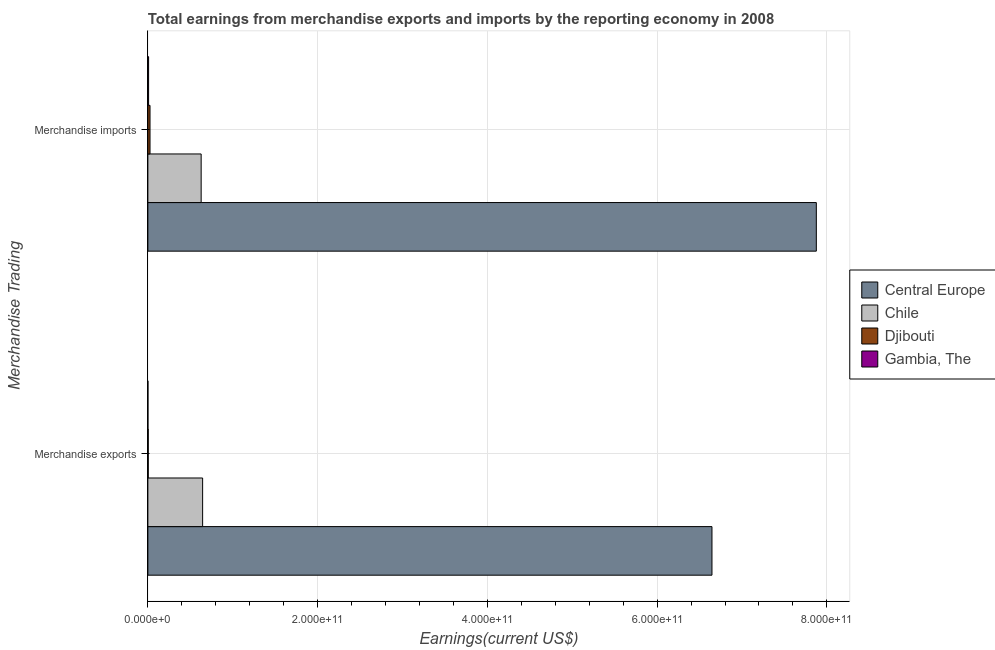How many different coloured bars are there?
Offer a very short reply. 4. How many groups of bars are there?
Provide a short and direct response. 2. What is the earnings from merchandise exports in Chile?
Keep it short and to the point. 6.45e+1. Across all countries, what is the maximum earnings from merchandise imports?
Offer a terse response. 7.88e+11. Across all countries, what is the minimum earnings from merchandise imports?
Ensure brevity in your answer.  8.60e+08. In which country was the earnings from merchandise imports maximum?
Keep it short and to the point. Central Europe. In which country was the earnings from merchandise exports minimum?
Your response must be concise. Gambia, The. What is the total earnings from merchandise imports in the graph?
Provide a short and direct response. 8.54e+11. What is the difference between the earnings from merchandise imports in Djibouti and that in Gambia, The?
Offer a terse response. 1.68e+09. What is the difference between the earnings from merchandise imports in Chile and the earnings from merchandise exports in Djibouti?
Provide a short and direct response. 6.24e+1. What is the average earnings from merchandise imports per country?
Your answer should be compact. 2.13e+11. What is the difference between the earnings from merchandise exports and earnings from merchandise imports in Djibouti?
Give a very brief answer. -2.10e+09. What is the ratio of the earnings from merchandise exports in Djibouti to that in Central Europe?
Make the answer very short. 0. Is the earnings from merchandise imports in Chile less than that in Djibouti?
Offer a terse response. No. In how many countries, is the earnings from merchandise exports greater than the average earnings from merchandise exports taken over all countries?
Offer a very short reply. 1. What does the 2nd bar from the top in Merchandise imports represents?
Give a very brief answer. Djibouti. What does the 4th bar from the bottom in Merchandise imports represents?
Ensure brevity in your answer.  Gambia, The. How many bars are there?
Your answer should be compact. 8. What is the difference between two consecutive major ticks on the X-axis?
Give a very brief answer. 2.00e+11. Are the values on the major ticks of X-axis written in scientific E-notation?
Offer a terse response. Yes. Where does the legend appear in the graph?
Ensure brevity in your answer.  Center right. How many legend labels are there?
Offer a terse response. 4. What is the title of the graph?
Your response must be concise. Total earnings from merchandise exports and imports by the reporting economy in 2008. Does "Argentina" appear as one of the legend labels in the graph?
Ensure brevity in your answer.  No. What is the label or title of the X-axis?
Keep it short and to the point. Earnings(current US$). What is the label or title of the Y-axis?
Provide a succinct answer. Merchandise Trading. What is the Earnings(current US$) of Central Europe in Merchandise exports?
Your response must be concise. 6.65e+11. What is the Earnings(current US$) in Chile in Merchandise exports?
Your answer should be very brief. 6.45e+1. What is the Earnings(current US$) of Djibouti in Merchandise exports?
Keep it short and to the point. 4.36e+08. What is the Earnings(current US$) of Gambia, The in Merchandise exports?
Offer a very short reply. 5.09e+07. What is the Earnings(current US$) in Central Europe in Merchandise imports?
Your answer should be compact. 7.88e+11. What is the Earnings(current US$) of Chile in Merchandise imports?
Your response must be concise. 6.28e+1. What is the Earnings(current US$) in Djibouti in Merchandise imports?
Your response must be concise. 2.54e+09. What is the Earnings(current US$) in Gambia, The in Merchandise imports?
Your response must be concise. 8.60e+08. Across all Merchandise Trading, what is the maximum Earnings(current US$) of Central Europe?
Offer a terse response. 7.88e+11. Across all Merchandise Trading, what is the maximum Earnings(current US$) of Chile?
Make the answer very short. 6.45e+1. Across all Merchandise Trading, what is the maximum Earnings(current US$) in Djibouti?
Keep it short and to the point. 2.54e+09. Across all Merchandise Trading, what is the maximum Earnings(current US$) of Gambia, The?
Your response must be concise. 8.60e+08. Across all Merchandise Trading, what is the minimum Earnings(current US$) in Central Europe?
Give a very brief answer. 6.65e+11. Across all Merchandise Trading, what is the minimum Earnings(current US$) of Chile?
Provide a succinct answer. 6.28e+1. Across all Merchandise Trading, what is the minimum Earnings(current US$) of Djibouti?
Ensure brevity in your answer.  4.36e+08. Across all Merchandise Trading, what is the minimum Earnings(current US$) in Gambia, The?
Ensure brevity in your answer.  5.09e+07. What is the total Earnings(current US$) of Central Europe in the graph?
Give a very brief answer. 1.45e+12. What is the total Earnings(current US$) of Chile in the graph?
Your answer should be compact. 1.27e+11. What is the total Earnings(current US$) in Djibouti in the graph?
Offer a very short reply. 2.97e+09. What is the total Earnings(current US$) in Gambia, The in the graph?
Ensure brevity in your answer.  9.11e+08. What is the difference between the Earnings(current US$) in Central Europe in Merchandise exports and that in Merchandise imports?
Provide a succinct answer. -1.23e+11. What is the difference between the Earnings(current US$) in Chile in Merchandise exports and that in Merchandise imports?
Keep it short and to the point. 1.72e+09. What is the difference between the Earnings(current US$) in Djibouti in Merchandise exports and that in Merchandise imports?
Keep it short and to the point. -2.10e+09. What is the difference between the Earnings(current US$) in Gambia, The in Merchandise exports and that in Merchandise imports?
Give a very brief answer. -8.09e+08. What is the difference between the Earnings(current US$) of Central Europe in Merchandise exports and the Earnings(current US$) of Chile in Merchandise imports?
Your response must be concise. 6.02e+11. What is the difference between the Earnings(current US$) in Central Europe in Merchandise exports and the Earnings(current US$) in Djibouti in Merchandise imports?
Your answer should be very brief. 6.62e+11. What is the difference between the Earnings(current US$) of Central Europe in Merchandise exports and the Earnings(current US$) of Gambia, The in Merchandise imports?
Your response must be concise. 6.64e+11. What is the difference between the Earnings(current US$) in Chile in Merchandise exports and the Earnings(current US$) in Djibouti in Merchandise imports?
Make the answer very short. 6.20e+1. What is the difference between the Earnings(current US$) in Chile in Merchandise exports and the Earnings(current US$) in Gambia, The in Merchandise imports?
Your response must be concise. 6.36e+1. What is the difference between the Earnings(current US$) in Djibouti in Merchandise exports and the Earnings(current US$) in Gambia, The in Merchandise imports?
Keep it short and to the point. -4.24e+08. What is the average Earnings(current US$) of Central Europe per Merchandise Trading?
Provide a short and direct response. 7.26e+11. What is the average Earnings(current US$) in Chile per Merchandise Trading?
Offer a very short reply. 6.36e+1. What is the average Earnings(current US$) of Djibouti per Merchandise Trading?
Give a very brief answer. 1.49e+09. What is the average Earnings(current US$) in Gambia, The per Merchandise Trading?
Your response must be concise. 4.56e+08. What is the difference between the Earnings(current US$) of Central Europe and Earnings(current US$) of Chile in Merchandise exports?
Offer a very short reply. 6.00e+11. What is the difference between the Earnings(current US$) in Central Europe and Earnings(current US$) in Djibouti in Merchandise exports?
Offer a terse response. 6.64e+11. What is the difference between the Earnings(current US$) of Central Europe and Earnings(current US$) of Gambia, The in Merchandise exports?
Give a very brief answer. 6.65e+11. What is the difference between the Earnings(current US$) in Chile and Earnings(current US$) in Djibouti in Merchandise exports?
Give a very brief answer. 6.41e+1. What is the difference between the Earnings(current US$) of Chile and Earnings(current US$) of Gambia, The in Merchandise exports?
Your answer should be very brief. 6.45e+1. What is the difference between the Earnings(current US$) of Djibouti and Earnings(current US$) of Gambia, The in Merchandise exports?
Ensure brevity in your answer.  3.85e+08. What is the difference between the Earnings(current US$) of Central Europe and Earnings(current US$) of Chile in Merchandise imports?
Ensure brevity in your answer.  7.25e+11. What is the difference between the Earnings(current US$) in Central Europe and Earnings(current US$) in Djibouti in Merchandise imports?
Make the answer very short. 7.85e+11. What is the difference between the Earnings(current US$) in Central Europe and Earnings(current US$) in Gambia, The in Merchandise imports?
Provide a short and direct response. 7.87e+11. What is the difference between the Earnings(current US$) of Chile and Earnings(current US$) of Djibouti in Merchandise imports?
Make the answer very short. 6.02e+1. What is the difference between the Earnings(current US$) in Chile and Earnings(current US$) in Gambia, The in Merchandise imports?
Give a very brief answer. 6.19e+1. What is the difference between the Earnings(current US$) of Djibouti and Earnings(current US$) of Gambia, The in Merchandise imports?
Keep it short and to the point. 1.68e+09. What is the ratio of the Earnings(current US$) of Central Europe in Merchandise exports to that in Merchandise imports?
Give a very brief answer. 0.84. What is the ratio of the Earnings(current US$) in Chile in Merchandise exports to that in Merchandise imports?
Keep it short and to the point. 1.03. What is the ratio of the Earnings(current US$) in Djibouti in Merchandise exports to that in Merchandise imports?
Offer a terse response. 0.17. What is the ratio of the Earnings(current US$) in Gambia, The in Merchandise exports to that in Merchandise imports?
Offer a terse response. 0.06. What is the difference between the highest and the second highest Earnings(current US$) in Central Europe?
Provide a succinct answer. 1.23e+11. What is the difference between the highest and the second highest Earnings(current US$) in Chile?
Offer a very short reply. 1.72e+09. What is the difference between the highest and the second highest Earnings(current US$) in Djibouti?
Make the answer very short. 2.10e+09. What is the difference between the highest and the second highest Earnings(current US$) in Gambia, The?
Keep it short and to the point. 8.09e+08. What is the difference between the highest and the lowest Earnings(current US$) of Central Europe?
Offer a terse response. 1.23e+11. What is the difference between the highest and the lowest Earnings(current US$) in Chile?
Offer a very short reply. 1.72e+09. What is the difference between the highest and the lowest Earnings(current US$) in Djibouti?
Your answer should be very brief. 2.10e+09. What is the difference between the highest and the lowest Earnings(current US$) in Gambia, The?
Provide a short and direct response. 8.09e+08. 